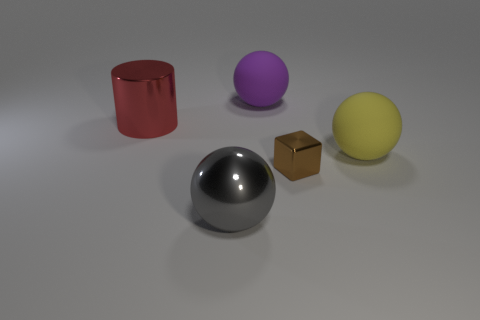Add 1 big red cylinders. How many objects exist? 6 Subtract all large gray metal spheres. How many spheres are left? 2 Subtract all blocks. How many objects are left? 4 Subtract 1 cylinders. How many cylinders are left? 0 Add 5 blue objects. How many blue objects exist? 5 Subtract all yellow balls. How many balls are left? 2 Subtract 1 brown cubes. How many objects are left? 4 Subtract all yellow cylinders. Subtract all purple balls. How many cylinders are left? 1 Subtract all small cyan rubber spheres. Subtract all big yellow things. How many objects are left? 4 Add 5 big metal cylinders. How many big metal cylinders are left? 6 